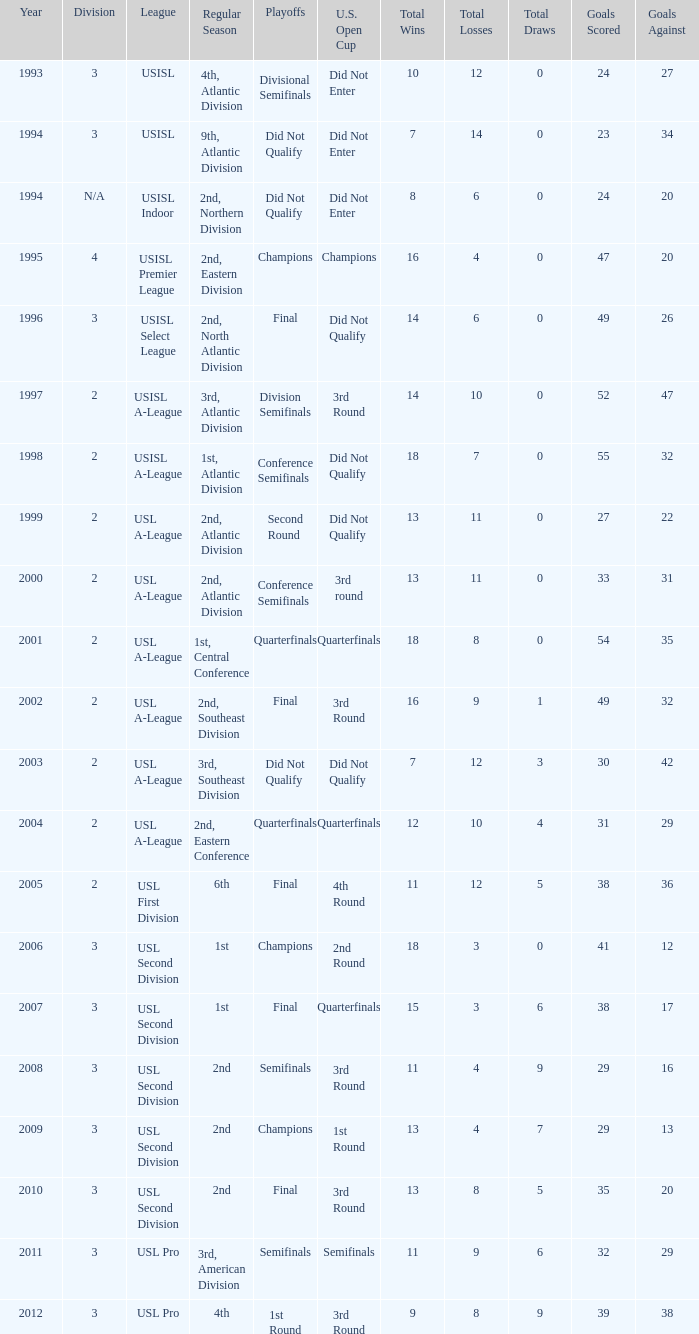How many division  did not qualify for u.s. open cup in 2003 2.0. 